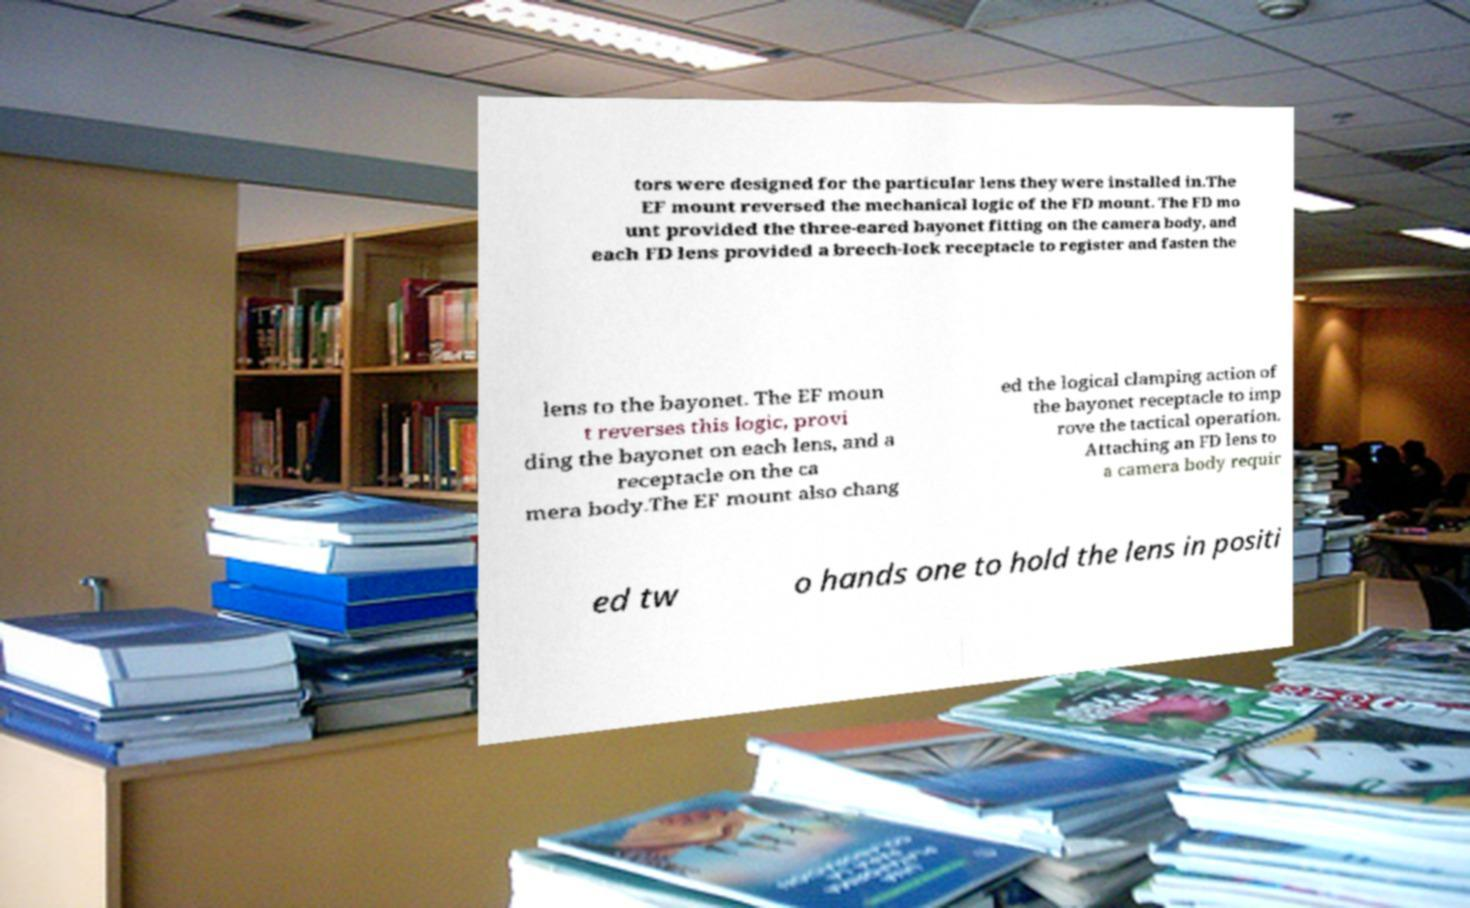What messages or text are displayed in this image? I need them in a readable, typed format. tors were designed for the particular lens they were installed in.The EF mount reversed the mechanical logic of the FD mount. The FD mo unt provided the three-eared bayonet fitting on the camera body, and each FD lens provided a breech-lock receptacle to register and fasten the lens to the bayonet. The EF moun t reverses this logic, provi ding the bayonet on each lens, and a receptacle on the ca mera body.The EF mount also chang ed the logical clamping action of the bayonet receptacle to imp rove the tactical operation. Attaching an FD lens to a camera body requir ed tw o hands one to hold the lens in positi 